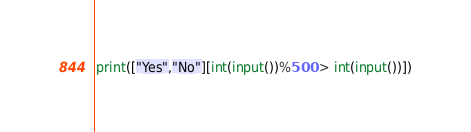<code> <loc_0><loc_0><loc_500><loc_500><_Python_>print(["Yes","No"][int(input())%500 > int(input())])</code> 